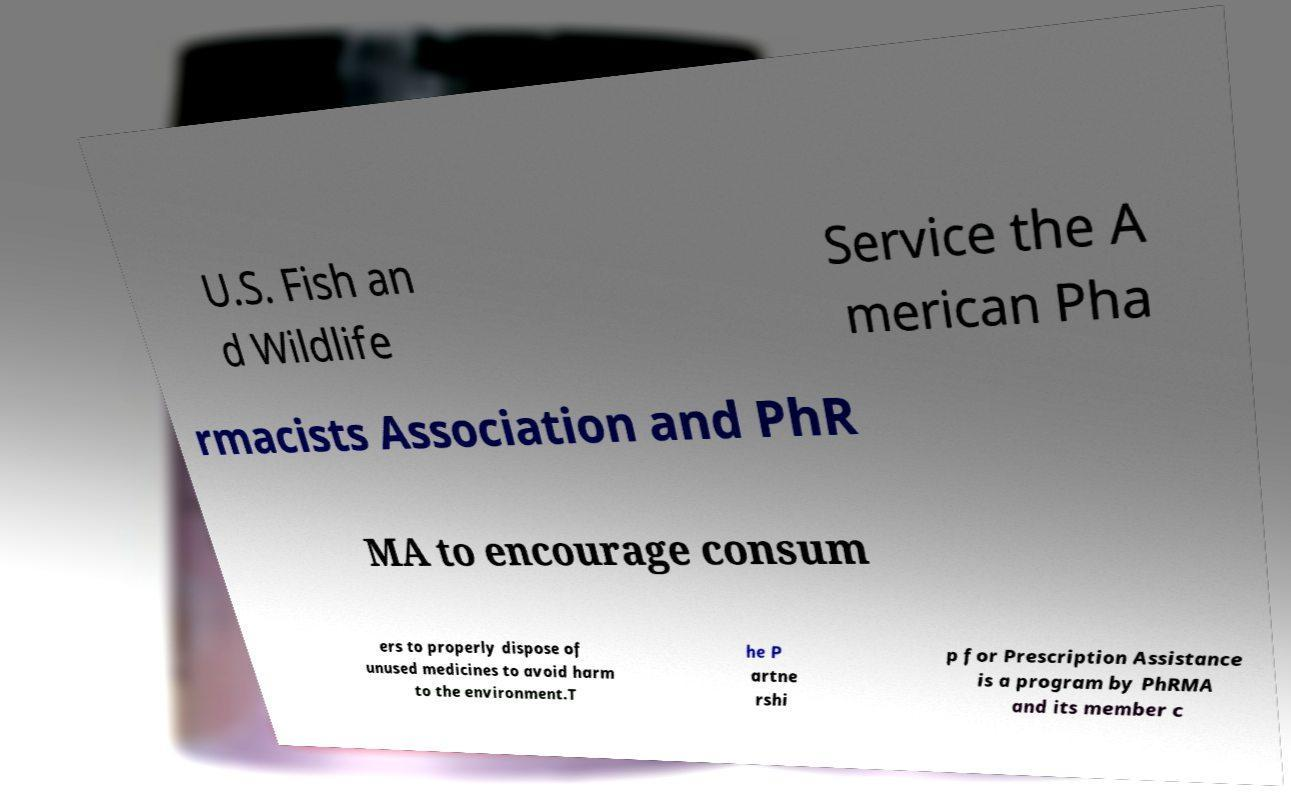For documentation purposes, I need the text within this image transcribed. Could you provide that? U.S. Fish an d Wildlife Service the A merican Pha rmacists Association and PhR MA to encourage consum ers to properly dispose of unused medicines to avoid harm to the environment.T he P artne rshi p for Prescription Assistance is a program by PhRMA and its member c 